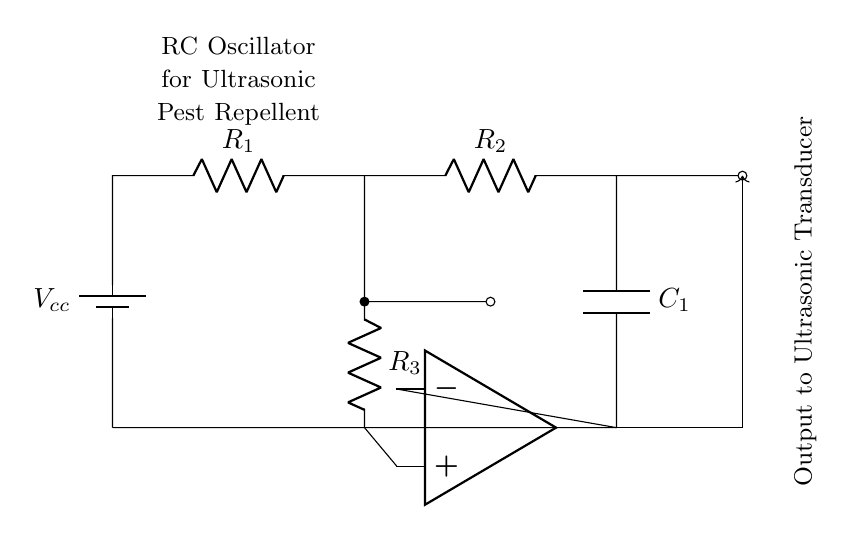What power supply is used in this circuit? The circuit features a battery labeled as Vcc, indicating it is the power supply source.
Answer: Vcc What are the components of this RC oscillator? The components include two resistors (R1 and R2), one capacitor (C1), and an operational amplifier.
Answer: R1, R2, C1, op amp What is the purpose of the op amp in this circuit? The operational amplifier functions to amplify the oscillation signal and drive the ultrasonic transducer, facilitating sound generation.
Answer: Amplifying the signal How many resistors are used in this circuit? There are three resistors, namely R1, R2, and R3, which are responsible for setting the time constant and feedback in the oscillator.
Answer: Three What does the output from the op amp drive? The output from the op amp drives the ultrasonic transducer, converting electrical signals into ultrasonic waves for pest repelling.
Answer: Ultrasonic transducer What determines the frequency of the oscillator in this circuit? The frequency of the oscillator is determined by the values of resistors R1, R2, R3, and capacitor C1, as they set the charge and discharge time through the capacitor.
Answer: R1, R2, R3, C1 What is the connection configuration of R1 and R2 in this circuit? Resistors R1 and R2 are connected in series, forming part of the RC timing network of the oscillator circuit.
Answer: Series 